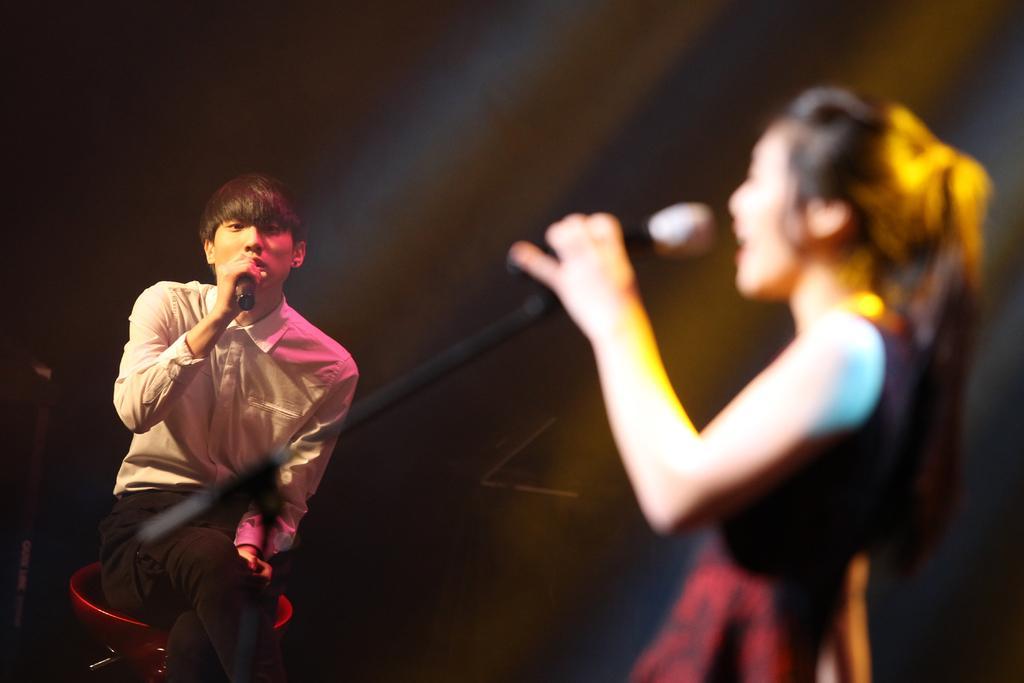Please provide a concise description of this image. This is an image clicked in the dark. On the right side I can see a woman standing and singing a song by holding a mike in hand. On the left side I can see a man wearing white color shirt, sitting on a chair and holding a mike in hand. 